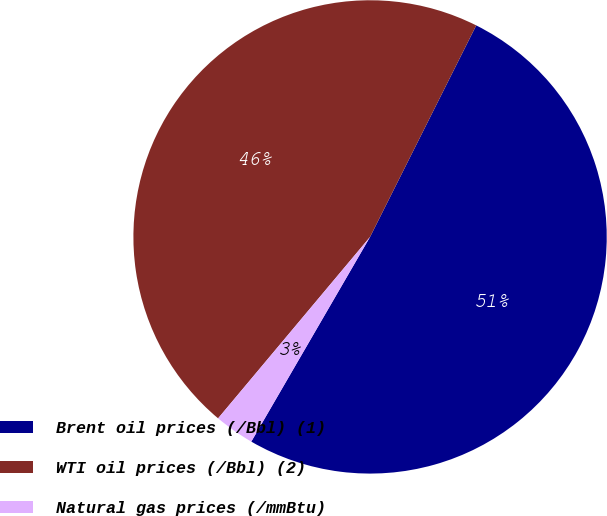Convert chart. <chart><loc_0><loc_0><loc_500><loc_500><pie_chart><fcel>Brent oil prices (/Bbl) (1)<fcel>WTI oil prices (/Bbl) (2)<fcel>Natural gas prices (/mmBtu)<nl><fcel>50.97%<fcel>46.31%<fcel>2.73%<nl></chart> 